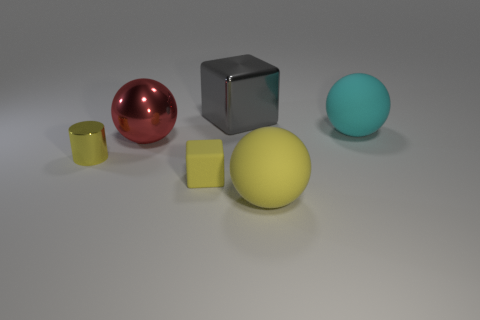There is a big sphere that is on the left side of the big rubber sphere that is in front of the cyan ball; are there any yellow matte blocks left of it?
Provide a succinct answer. No. How many cubes are cyan matte objects or small yellow rubber objects?
Provide a short and direct response. 1. Is the shape of the big yellow rubber thing the same as the large metallic object that is on the right side of the big red metallic ball?
Give a very brief answer. No. Is the number of yellow spheres behind the big gray thing less than the number of yellow matte objects?
Make the answer very short. Yes. There is a yellow matte cube; are there any tiny rubber blocks to the left of it?
Provide a succinct answer. No. Are there any other yellow objects of the same shape as the large yellow thing?
Your answer should be very brief. No. There is a gray metal thing that is the same size as the yellow matte sphere; what is its shape?
Give a very brief answer. Cube. What number of things are big matte objects behind the large yellow ball or gray rubber blocks?
Ensure brevity in your answer.  1. Is the color of the metal ball the same as the rubber block?
Your response must be concise. No. There is a block that is behind the tiny cylinder; how big is it?
Your response must be concise. Large. 